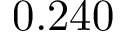<formula> <loc_0><loc_0><loc_500><loc_500>0 . 2 4 0</formula> 